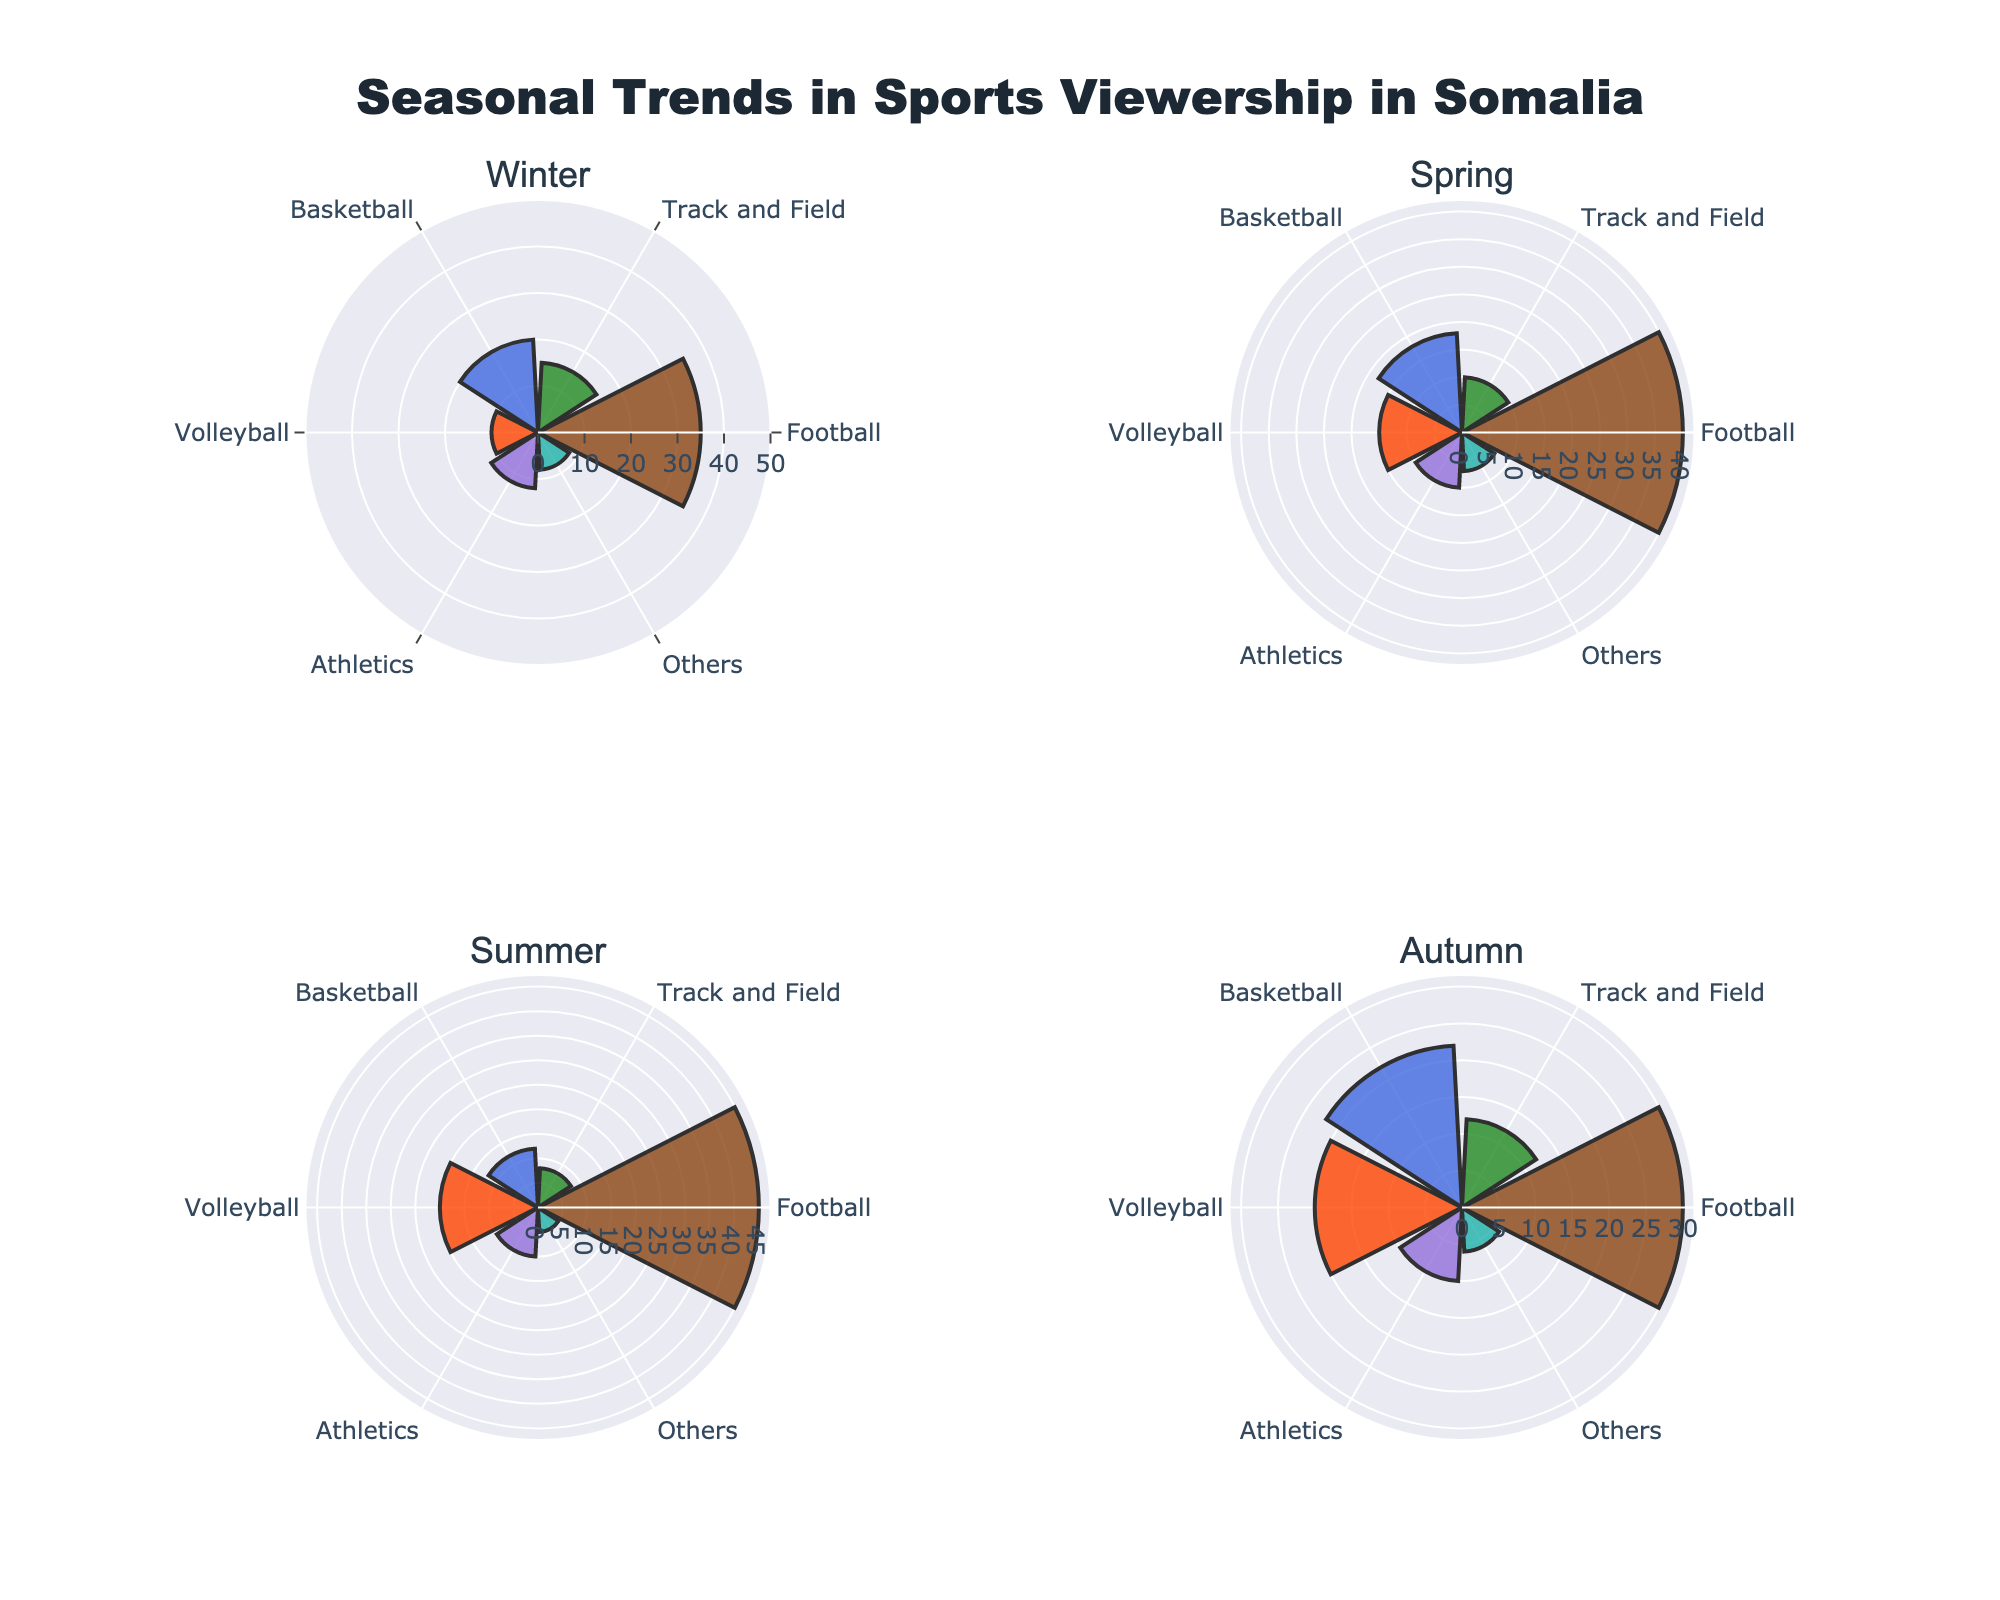Which sport has the highest viewership percentage in Winter? By looking at the Winter section, Football has the longest bar, indicating the highest viewership percentage.
Answer: Football What is the total percentage of viewership for Football across all seasons? Sum up the percentages for Football in all four seasons: Winter (35%), Spring (40%), Summer (45%), and Autumn (30%). The total is 35 + 40 + 45 + 30 = 150.
Answer: 150 Which season shows the highest viewership percentage for Volleyball? Compare the heights of the bars for Volleyball across the four seasons. Summer and Autumn both have the highest, with 20%.
Answer: Summer and Autumn What is the difference in viewership percentage for Track and Field between Summer and Spring? In Summer, Track and Field has an 8% viewership, and in Spring, it has 10%. The difference is 10 - 8 = 2.
Answer: 2 Which sport has the lowest viewership percentage in Summer? By inspecting the Summer section, 'Others' has the shortest bar, indicating the lowest percentage at 5%.
Answer: Others How does the viewership in Athletics change from Winter to Autumn? Check the lengths of the bars for Athletics in both Winter and Autumn. Winter has 12% and Autumn has 10%, so it decreases by 2%.
Answer: Decreases by 2% Which season has the highest overall viewership for all sports combined? Add the percentages for each sport in each season. For Winter: 35+15+20+10+12+8 = 100, Spring: 40+10+18+15+10+7 = 100, Summer: 45+8+12+20+10+5 = 100, Autumn: 30+12+22+20+10+6 = 100. All seasons sum up to 100%.
Answer: All seasons have equal total viewership In which season is Basketball viewership the second highest? By comparing the Basketball viewership across seasons, Winter is second highest with 20%, following Autumn at 22%.
Answer: Winter What is the percentage difference in Volleyball viewership between Winter and Spring? The viewership for Winter is 10% and for Spring is 15%. The difference is 15 - 10 = 5.
Answer: 5 